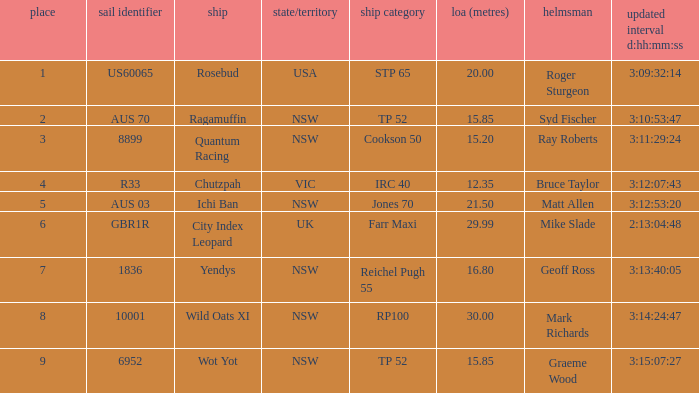How many yachts had a position of 3? 1.0. 